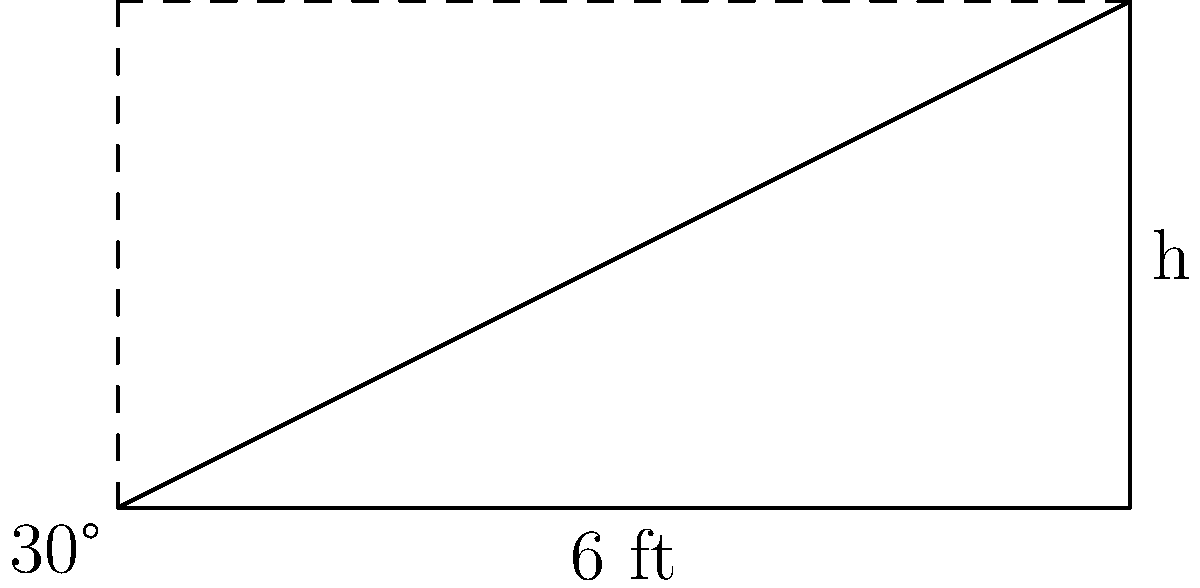At your local yoga studio, you're helping set up a new yoga mat stand. The stand leans against the wall at a 30° angle to the floor and extends 6 feet along the ground. Using the tangent function, calculate the height of the yoga mat stand to the nearest tenth of a foot. To solve this problem, we'll use the tangent function and follow these steps:

1) In a right triangle, tangent of an angle is the ratio of the opposite side to the adjacent side.

2) In this case:
   - The angle is 30°
   - The adjacent side (along the floor) is 6 feet
   - We need to find the opposite side (height)

3) We can write the equation:
   $\tan(30°) = \frac{\text{height}}{6}$

4) Rearrange the equation to solve for height:
   $\text{height} = 6 \times \tan(30°)$

5) Calculate:
   $\text{height} = 6 \times \tan(30°)$
   $= 6 \times 0.5773$ (using a calculator or trigonometric table)
   $= 3.4638$ feet

6) Rounding to the nearest tenth:
   $\text{height} \approx 3.5$ feet

Therefore, the height of the yoga mat stand is approximately 3.5 feet.
Answer: 3.5 feet 